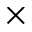Convert formula to latex. <formula><loc_0><loc_0><loc_500><loc_500>\times</formula> 